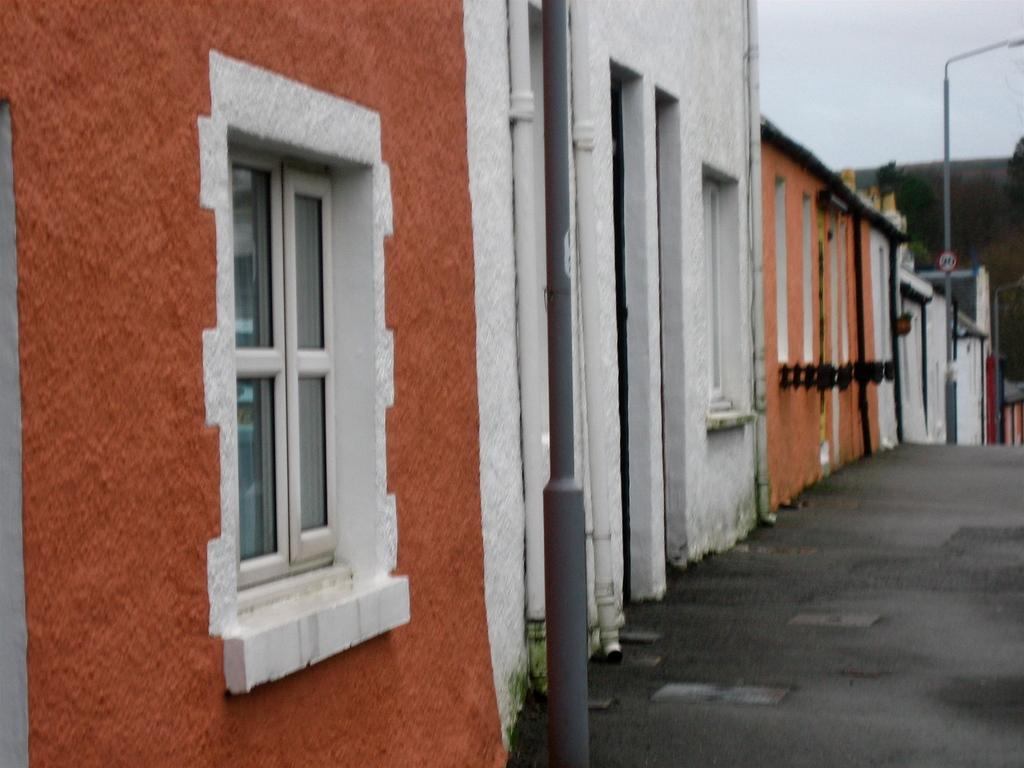What type of structures can be seen in the image? There are houses in the image. What else can be seen besides the houses? There are poles, a sign board, a road, trees, and the sky visible in the background of the image. What might be used for providing direction or information in the image? The sign board in the image might be used for providing direction or information. What type of vegetation is present in the image? Trees are present in the image. Can you see any fairies flying around the trees in the image? There are no fairies present in the image; it only shows houses, poles, a sign board, a road, trees, and the sky. What class of vehicles is allowed to use the road in the image? The image does not specify the class of vehicles allowed on the road, as it only shows the road and not any vehicles. 